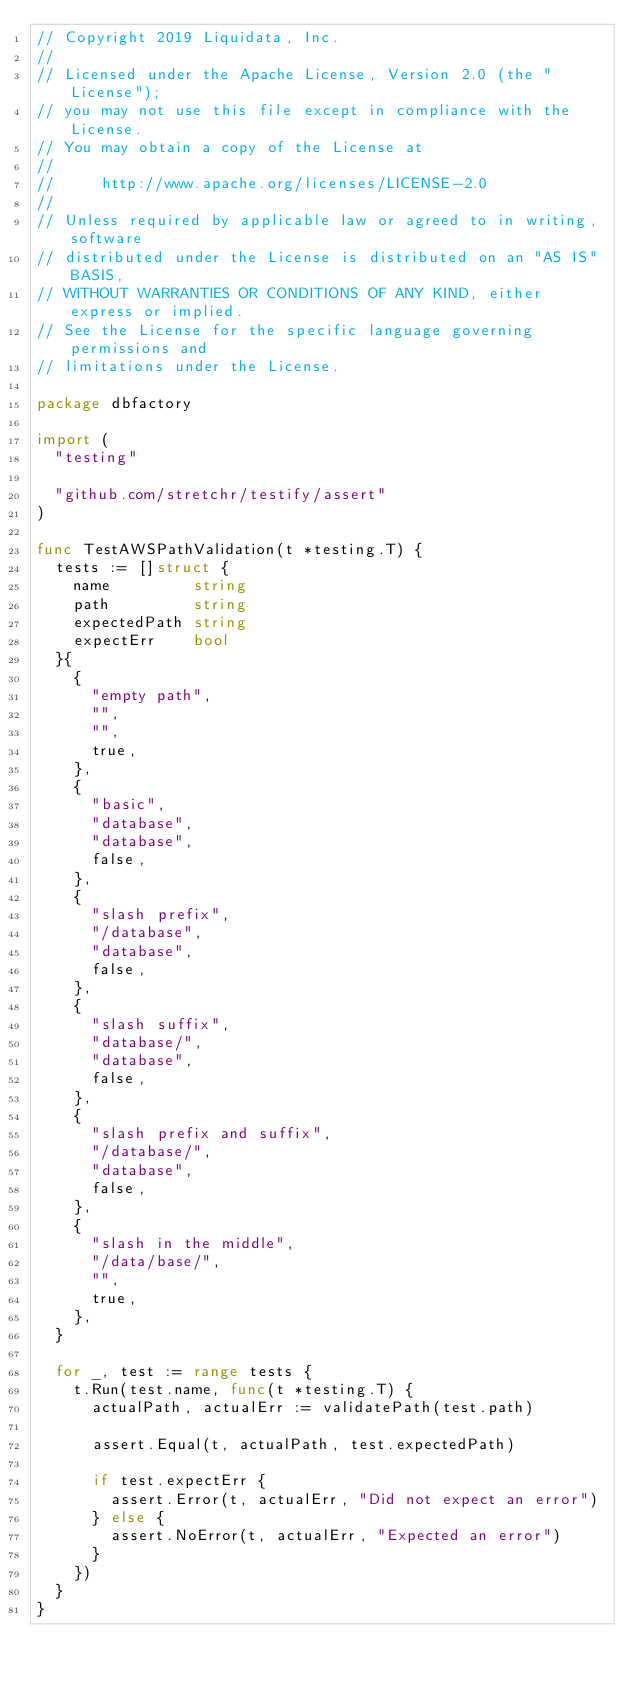<code> <loc_0><loc_0><loc_500><loc_500><_Go_>// Copyright 2019 Liquidata, Inc.
//
// Licensed under the Apache License, Version 2.0 (the "License");
// you may not use this file except in compliance with the License.
// You may obtain a copy of the License at
//
//     http://www.apache.org/licenses/LICENSE-2.0
//
// Unless required by applicable law or agreed to in writing, software
// distributed under the License is distributed on an "AS IS" BASIS,
// WITHOUT WARRANTIES OR CONDITIONS OF ANY KIND, either express or implied.
// See the License for the specific language governing permissions and
// limitations under the License.

package dbfactory

import (
	"testing"

	"github.com/stretchr/testify/assert"
)

func TestAWSPathValidation(t *testing.T) {
	tests := []struct {
		name         string
		path         string
		expectedPath string
		expectErr    bool
	}{
		{
			"empty path",
			"",
			"",
			true,
		},
		{
			"basic",
			"database",
			"database",
			false,
		},
		{
			"slash prefix",
			"/database",
			"database",
			false,
		},
		{
			"slash suffix",
			"database/",
			"database",
			false,
		},
		{
			"slash prefix and suffix",
			"/database/",
			"database",
			false,
		},
		{
			"slash in the middle",
			"/data/base/",
			"",
			true,
		},
	}

	for _, test := range tests {
		t.Run(test.name, func(t *testing.T) {
			actualPath, actualErr := validatePath(test.path)

			assert.Equal(t, actualPath, test.expectedPath)

			if test.expectErr {
				assert.Error(t, actualErr, "Did not expect an error")
			} else {
				assert.NoError(t, actualErr, "Expected an error")
			}
		})
	}
}
</code> 